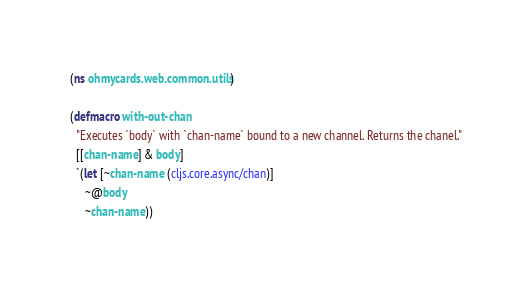<code> <loc_0><loc_0><loc_500><loc_500><_Clojure_>(ns ohmycards.web.common.utils)

(defmacro with-out-chan
  "Executes `body` with `chan-name` bound to a new channel. Returns the chanel."
  [[chan-name] & body]
  `(let [~chan-name (cljs.core.async/chan)]
     ~@body
     ~chan-name))
</code> 